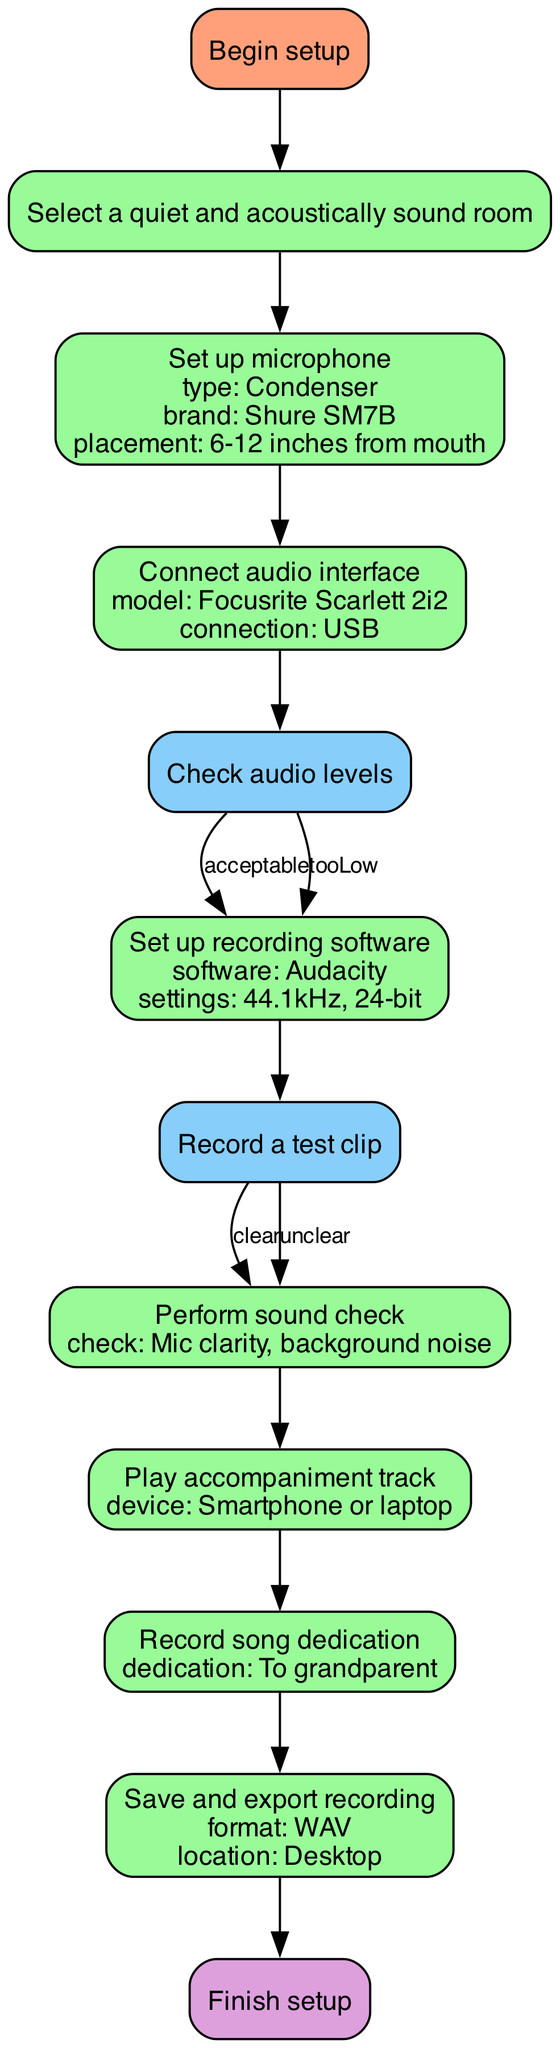What is the first action in the flowchart? The first action in the flowchart is "Select a quiet and acoustically sound room" represented by node ID 2.
Answer: Select a quiet and acoustically sound room How many nodes are present in the flowchart? The flowchart contains 12 nodes including Start and End nodes.
Answer: 12 What is the model of the audio interface? The audio interface model given in the flowchart is "Focusrite Scarlett 2i2" at node ID 4.
Answer: Focusrite Scarlett 2i2 What should you do if the audio levels are too low? If the audio levels are too low as per node ID 5, the action to take is "Adjust gain."
Answer: Adjust gain What is the final action before finishing setup? The last action before finishing the setup is "Save and export recording" listed under node ID 11.
Answer: Save and export recording What happens if the test clip is unclear? If the test clip is unclear, the flowchart advises to "Recheck setup" as indicated in node ID 7.
Answer: Recheck setup How is the device for playing the accompaniment track described? The device for playing the accompaniment track specified is either a "Smartphone or laptop," detailed in node ID 9.
Answer: Smartphone or laptop What is the sample rate and bit depth set for the recording software? The sample rate is "44.1kHz" and bit depth is "24-bit" for the recording software, as outlined in node ID 6.
Answer: 44.1kHz, 24-bit What decision follows the sound check? The decision that follows the sound check at node ID 8 is to "Record a test clip."
Answer: Record a test clip 